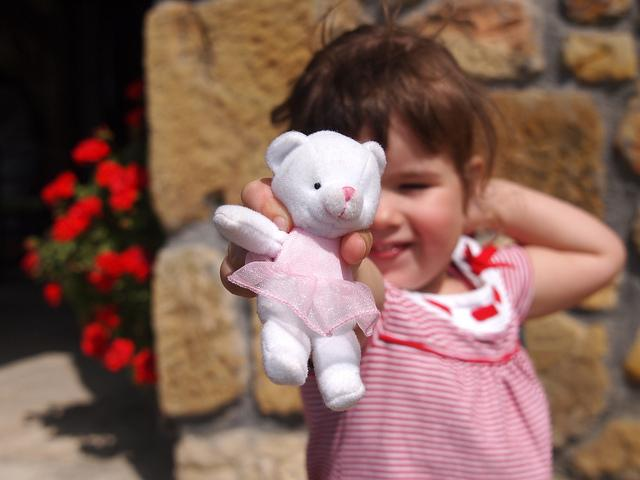What is she doing with the stuffed animal?

Choices:
A) showing it
B) breaking it
C) selling it
D) squeezing it squeezing it 